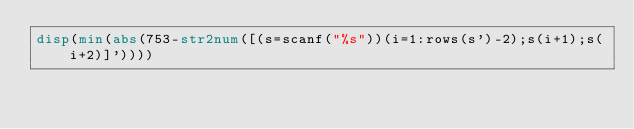Convert code to text. <code><loc_0><loc_0><loc_500><loc_500><_Octave_>disp(min(abs(753-str2num([(s=scanf("%s"))(i=1:rows(s')-2);s(i+1);s(i+2)]'))))</code> 